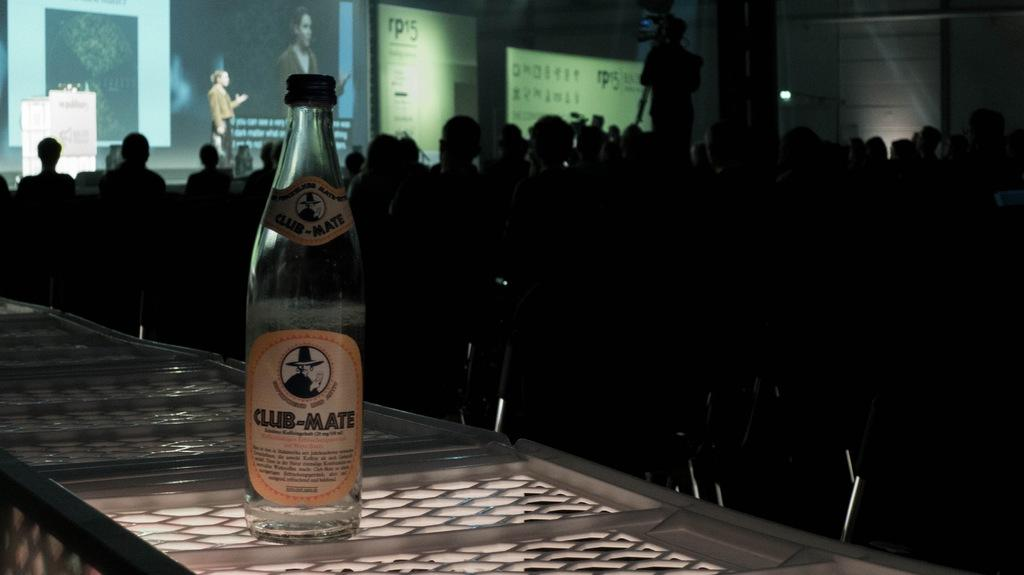<image>
Summarize the visual content of the image. Bottle of Club Mate in front of a group of people watching a presentation. 